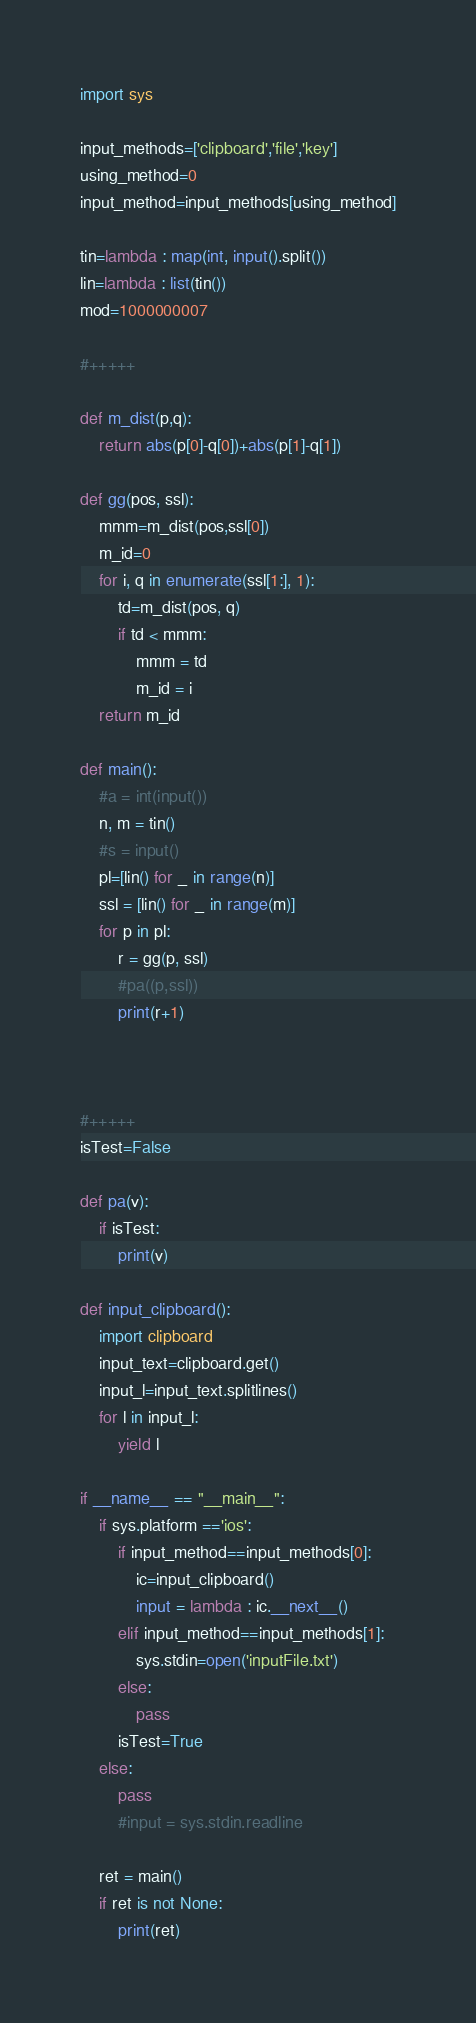<code> <loc_0><loc_0><loc_500><loc_500><_Python_>import sys

input_methods=['clipboard','file','key']
using_method=0
input_method=input_methods[using_method]

tin=lambda : map(int, input().split())
lin=lambda : list(tin())
mod=1000000007

#+++++

def m_dist(p,q):
	return abs(p[0]-q[0])+abs(p[1]-q[1])

def gg(pos, ssl):
	mmm=m_dist(pos,ssl[0])
	m_id=0
	for i, q in enumerate(ssl[1:], 1):
		td=m_dist(pos, q)
		if td < mmm:
			mmm = td
			m_id = i
	return m_id
		
def main():
	#a = int(input())
	n, m = tin()
	#s = input()
	pl=[lin() for _ in range(n)]
	ssl = [lin() for _ in range(m)]
	for p in pl:
		r = gg(p, ssl)
		#pa((p,ssl))
		print(r+1)
	
	
	
#+++++
isTest=False

def pa(v):
	if isTest:
		print(v)
		
def input_clipboard():
	import clipboard
	input_text=clipboard.get()
	input_l=input_text.splitlines()
	for l in input_l:
		yield l

if __name__ == "__main__":
	if sys.platform =='ios':
		if input_method==input_methods[0]:
			ic=input_clipboard()
			input = lambda : ic.__next__()
		elif input_method==input_methods[1]:
			sys.stdin=open('inputFile.txt')
		else:
			pass
		isTest=True
	else:
		pass
		#input = sys.stdin.readline
			
	ret = main()
	if ret is not None:
		print(ret)</code> 